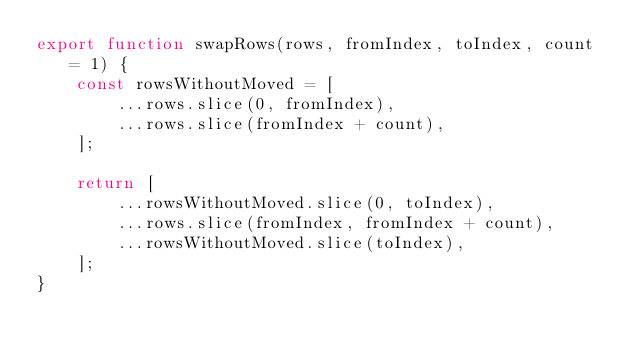<code> <loc_0><loc_0><loc_500><loc_500><_JavaScript_>export function swapRows(rows, fromIndex, toIndex, count = 1) {
    const rowsWithoutMoved = [
        ...rows.slice(0, fromIndex),
        ...rows.slice(fromIndex + count),
    ];

    return [
        ...rowsWithoutMoved.slice(0, toIndex),
        ...rows.slice(fromIndex, fromIndex + count),
        ...rowsWithoutMoved.slice(toIndex),
    ];
}
</code> 